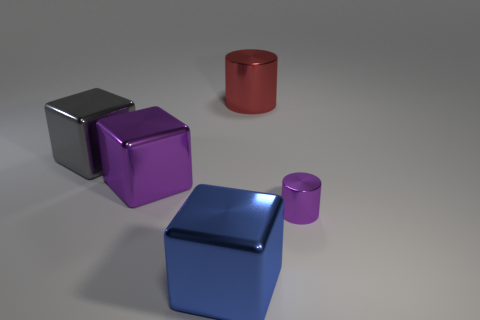There is a large blue metal cube; what number of small things are to the left of it?
Give a very brief answer. 0. Is there anything else that is the same size as the blue cube?
Your answer should be very brief. Yes. The other cylinder that is made of the same material as the purple cylinder is what color?
Give a very brief answer. Red. Do the large gray object and the red object have the same shape?
Ensure brevity in your answer.  No. How many objects are in front of the small shiny thing and behind the small shiny cylinder?
Provide a short and direct response. 0. How many rubber things are small yellow things or small purple objects?
Your answer should be compact. 0. There is a block in front of the purple object that is to the right of the large blue thing; what size is it?
Give a very brief answer. Large. There is a large block that is the same color as the tiny cylinder; what is its material?
Keep it short and to the point. Metal. Is there a gray thing behind the metal object that is in front of the metal cylinder in front of the gray metal object?
Make the answer very short. Yes. Is the cylinder that is behind the large gray cube made of the same material as the cube that is in front of the big purple metal thing?
Provide a succinct answer. Yes. 